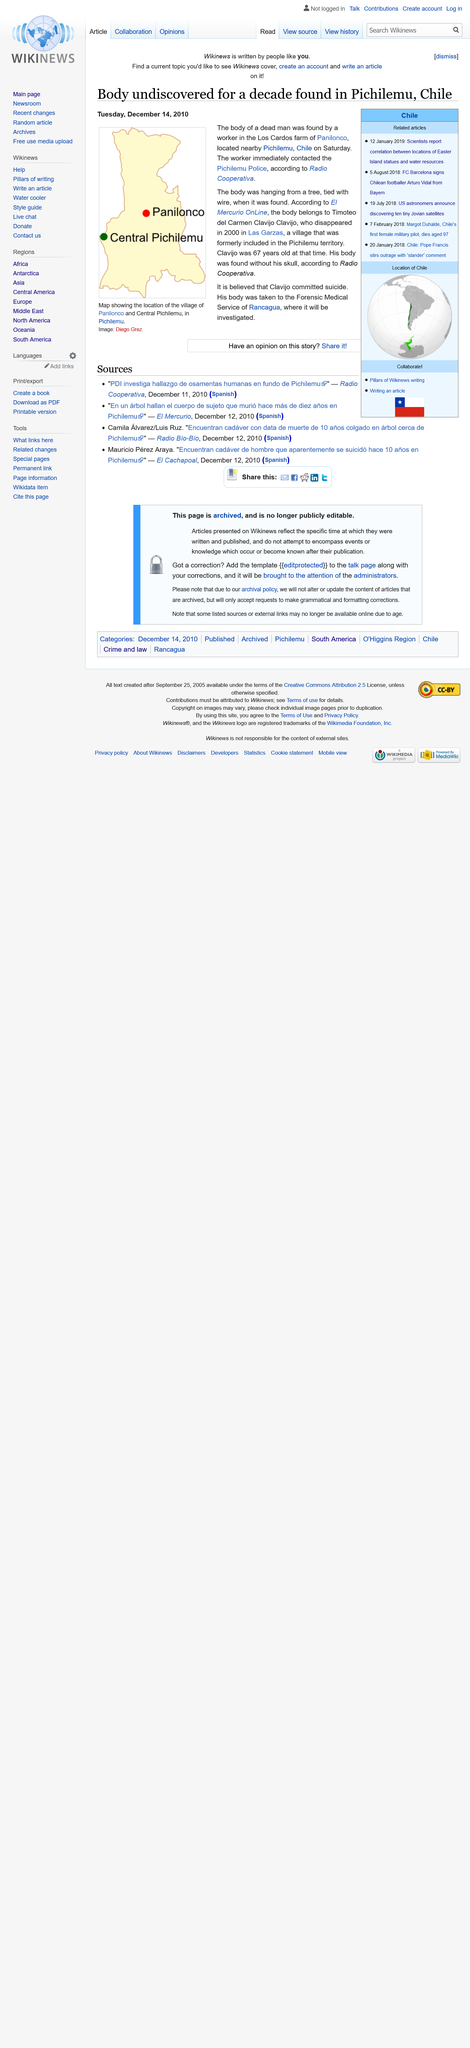Outline some significant characteristics in this image. The body belonged to Timoteo del Carmen Clavijo Clavijo. On March 12th, the body of a young woman was discovered in the Los Cardos Farm of Panilonco, located near Pichilemu, Chile. The image depicts a map displaying the location of the village in Panilonco and Pichilemu. 